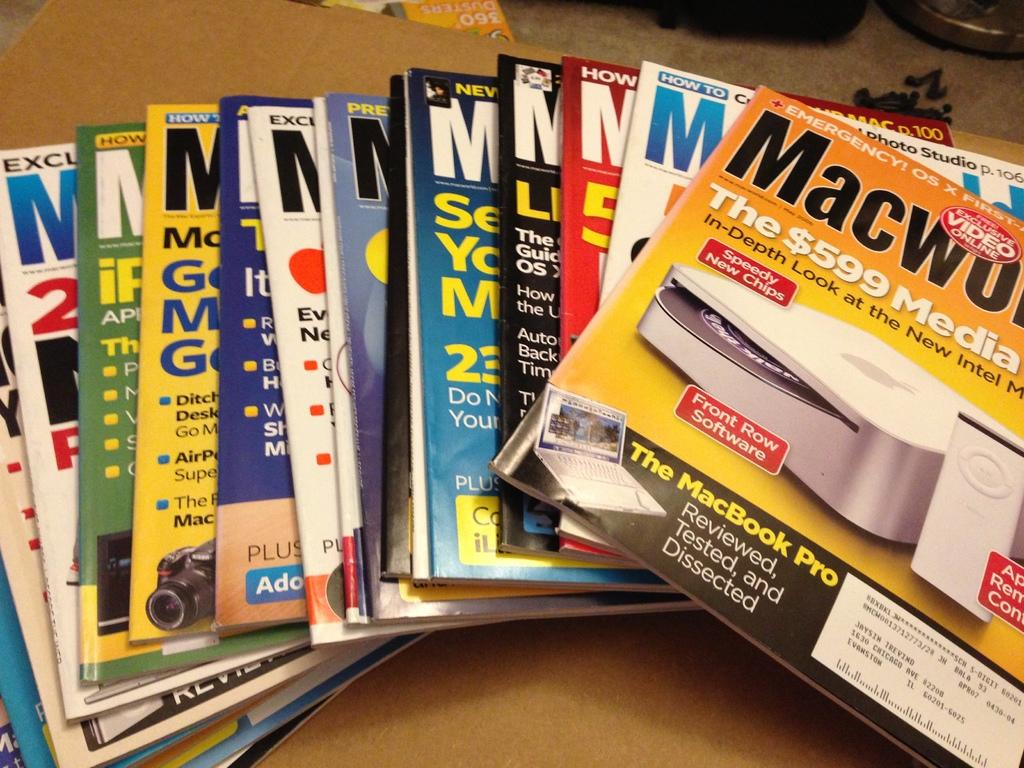<image>
Offer a succinct explanation of the picture presented. A variety of Macworld magazines are laid out on a table. 